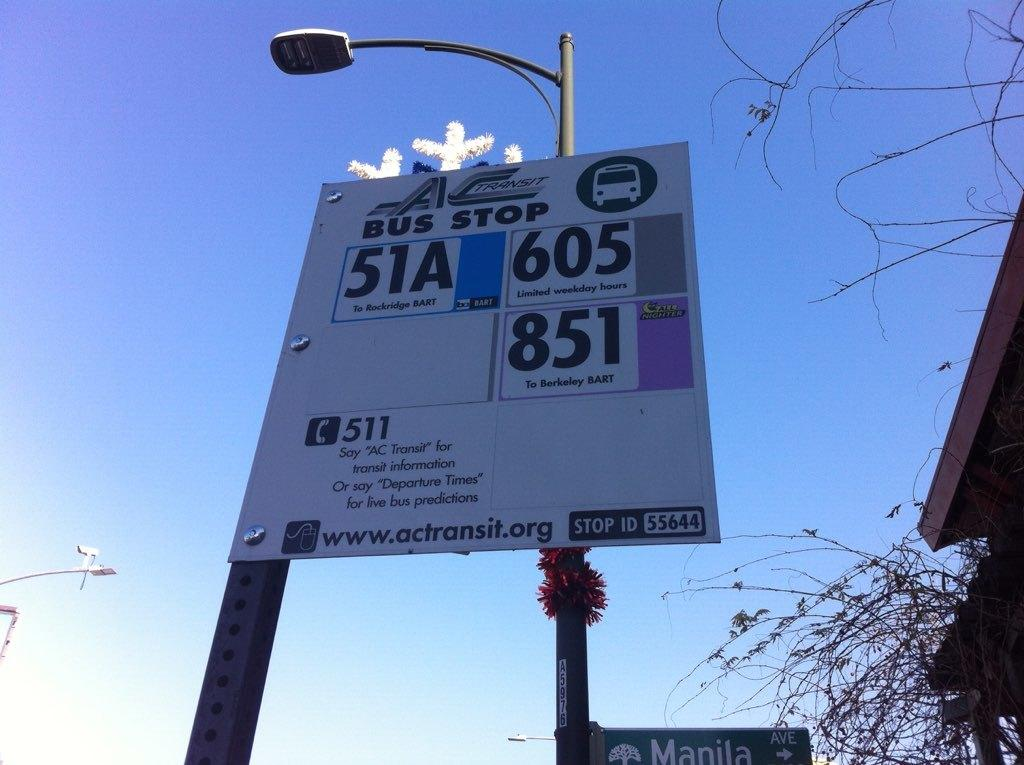Provide a one-sentence caption for the provided image. Bus stop 51A takes you to Rockridge BART. 